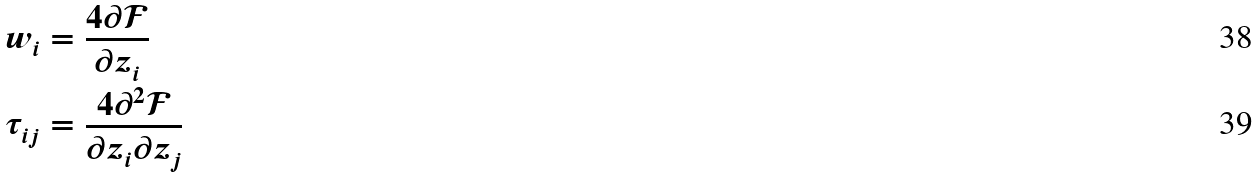Convert formula to latex. <formula><loc_0><loc_0><loc_500><loc_500>w _ { i } & = \frac { 4 \partial \mathcal { F } } { \partial z _ { i } } \\ \tau _ { i j } & = \frac { 4 \partial ^ { 2 } \mathcal { F } } { \partial z _ { i } \partial z _ { j } }</formula> 